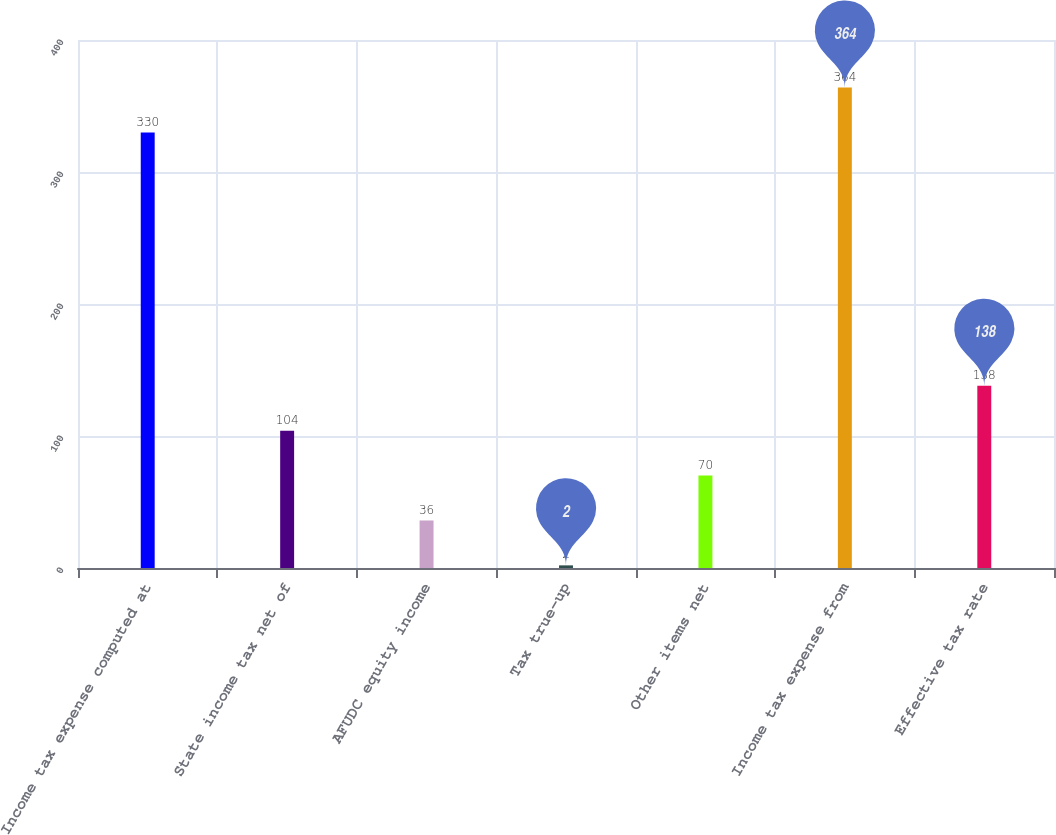Convert chart. <chart><loc_0><loc_0><loc_500><loc_500><bar_chart><fcel>Income tax expense computed at<fcel>State income tax net of<fcel>AFUDC equity income<fcel>Tax true-up<fcel>Other items net<fcel>Income tax expense from<fcel>Effective tax rate<nl><fcel>330<fcel>104<fcel>36<fcel>2<fcel>70<fcel>364<fcel>138<nl></chart> 